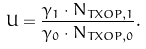Convert formula to latex. <formula><loc_0><loc_0><loc_500><loc_500>U = \frac { \gamma _ { 1 } \cdot N _ { T X O P , 1 } } { \gamma _ { 0 } \cdot N _ { T X O P , 0 } } .</formula> 